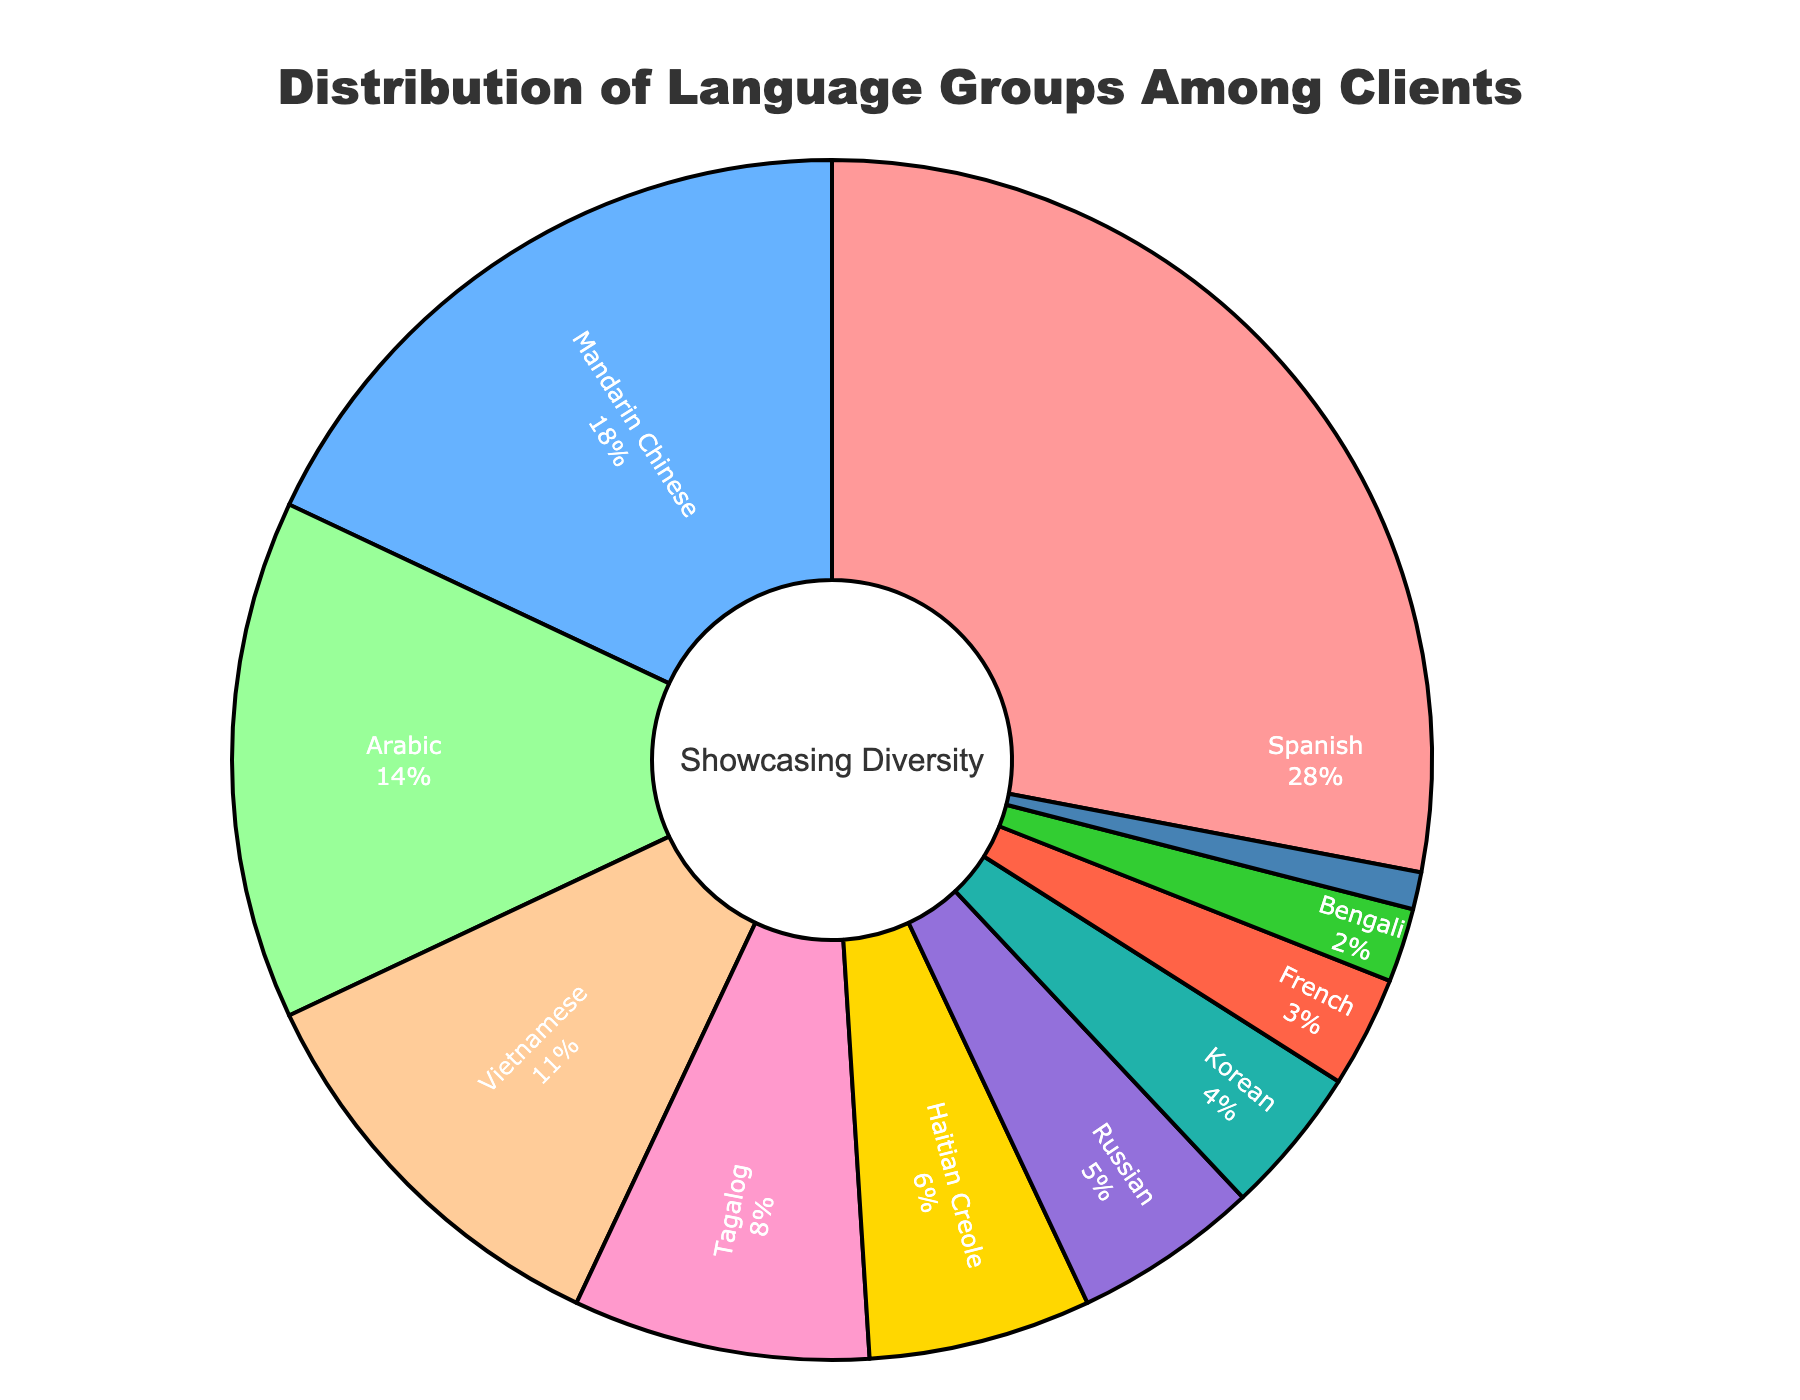What's the largest language group among clients? By examining the pie chart, the slice representing the Spanish language group is the largest. This indicates that Spanish is the most prevalent language among clients.
Answer: Spanish Which language group has a larger percentage, Arabic or Vietnamese? By comparing the slices in the pie chart for Arabic and Vietnamese, the Arabic group is larger at 14%, while the Vietnamese group is 11%.
Answer: Arabic What is the combined percentage of clients who speak Tagalog and Haitian Creole? The pie chart shows that Tagalog represents 8% and Haitian Creole represents 6%. Adding these two percentages together results in 8% + 6% = 14%.
Answer: 14% How many language groups have a percentage of 5% or less? By inspecting the pie chart, the language groups with 5% or less are: Russian (5%), Korean (4%), French (3%), Bengali (2%), and Portuguese (1%). There are 5 such language groups.
Answer: 5 Which language group has the smallest representation among clients? The smallest slice on the pie chart corresponds to the Portuguese language group, which has a representation of 1%.
Answer: Portuguese Is the percentage of clients who speak Mandarin Chinese greater than the combined percentage of those who speak Korean and French? Mandarin Chinese has a representation of 18%. The combined percentage for Korean (4%) and French (3%) is 4% + 3% = 7%. 18% is greater than 7%, so yes.
Answer: Yes What is the difference in percentage between clients who speak Spanish and those who speak Russian? The pie chart indicates that Spanish represents 28% while Russian represents 5%. The difference in percentage is 28% - 5% = 23%.
Answer: 23% How does the percentage of clients who speak Arabic compare to those who speak Tagalog visually by size? Visually in the pie chart, the slice for Arabic is larger than the slice for Tagalog. This confirms that Arabic at 14% is greater than Tagalog at 8%.
Answer: Arabic is larger How many language groups each have a representation of more than 10% of the clients? By reviewing the pie chart, the language groups with more than 10% are Spanish (28%), Mandarin Chinese (18%), Arabic (14%), and Vietnamese (11%). There are 4 such groups.
Answer: 4 What's the total percentage of clients from all the language groups displayed on the pie chart? Adding up all the percentages for each language group: 28% + 18% + 14% + 11% + 8% + 6% + 5% + 4% + 3% + 2% + 1% = 100%.
Answer: 100% 